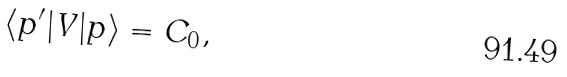<formula> <loc_0><loc_0><loc_500><loc_500>\langle { p } ^ { \prime } | V | { p } \rangle = C _ { 0 } ,</formula> 